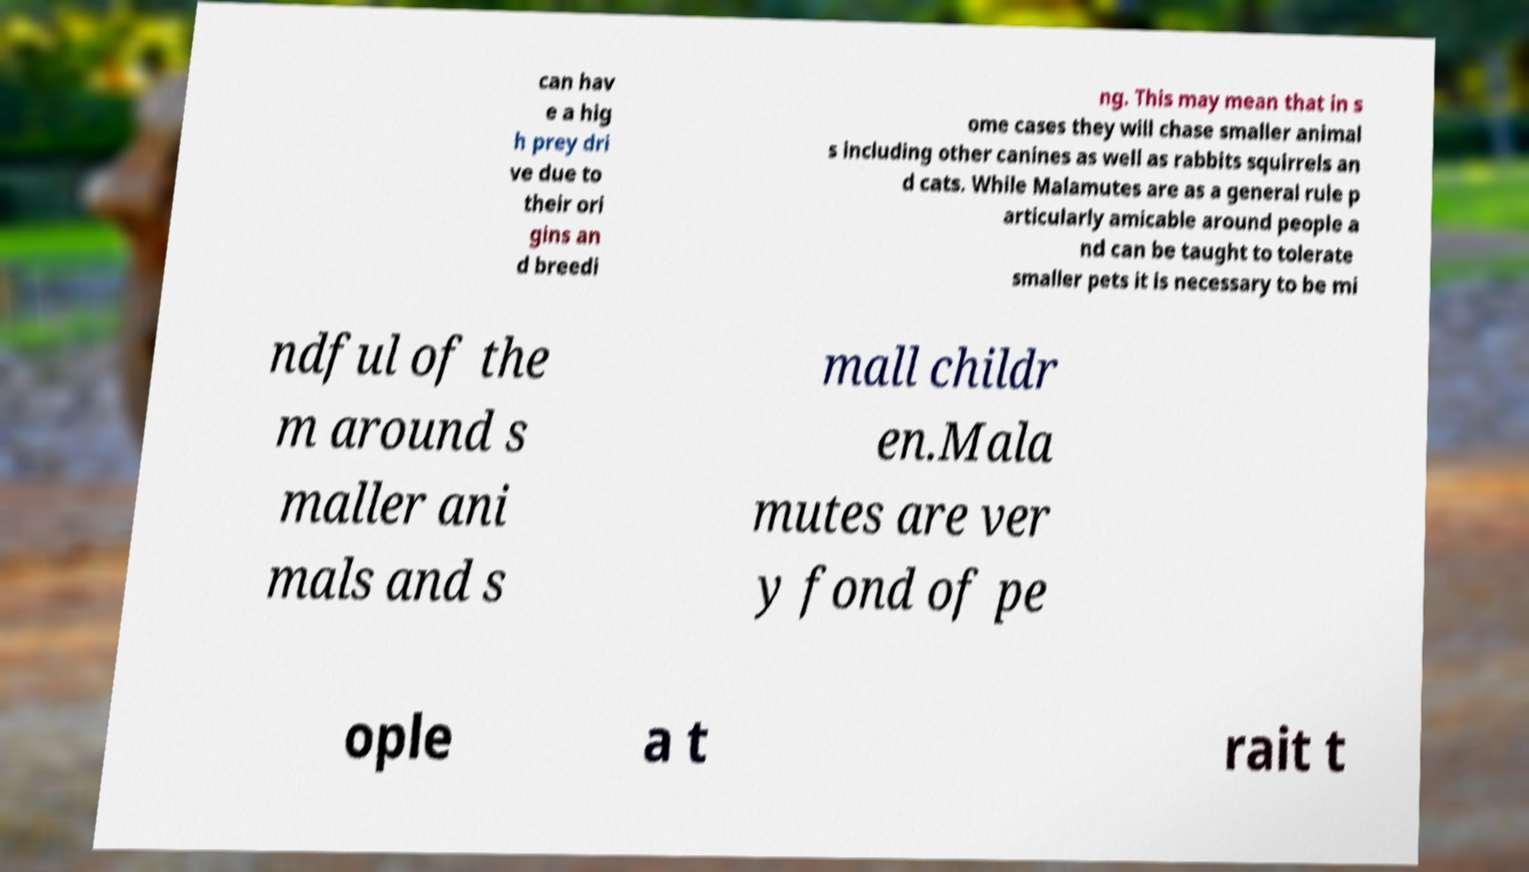I need the written content from this picture converted into text. Can you do that? can hav e a hig h prey dri ve due to their ori gins an d breedi ng. This may mean that in s ome cases they will chase smaller animal s including other canines as well as rabbits squirrels an d cats. While Malamutes are as a general rule p articularly amicable around people a nd can be taught to tolerate smaller pets it is necessary to be mi ndful of the m around s maller ani mals and s mall childr en.Mala mutes are ver y fond of pe ople a t rait t 